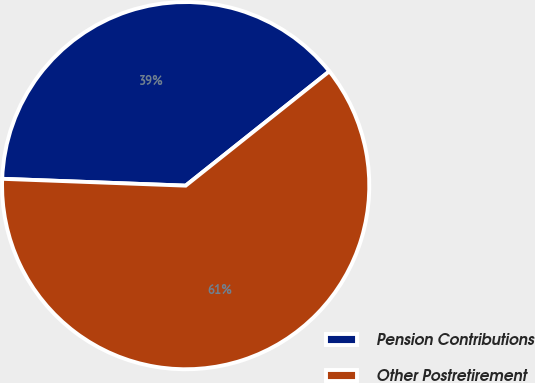Convert chart to OTSL. <chart><loc_0><loc_0><loc_500><loc_500><pie_chart><fcel>Pension Contributions<fcel>Other Postretirement<nl><fcel>38.71%<fcel>61.29%<nl></chart> 